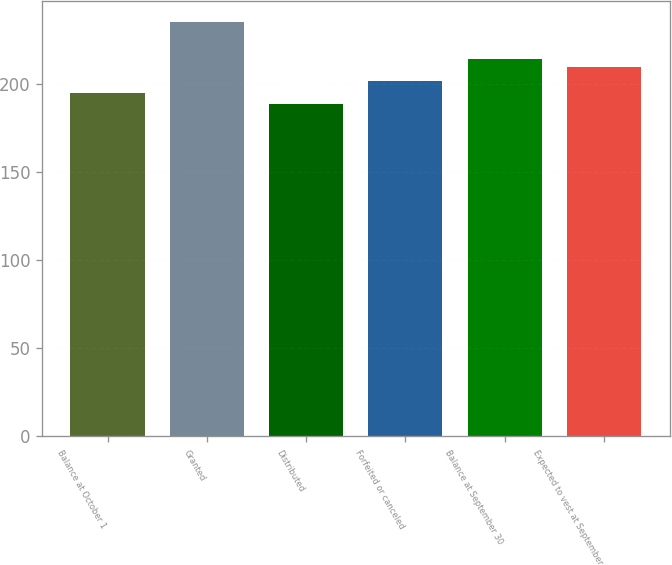Convert chart. <chart><loc_0><loc_0><loc_500><loc_500><bar_chart><fcel>Balance at October 1<fcel>Granted<fcel>Distributed<fcel>Forfeited or canceled<fcel>Balance at September 30<fcel>Expected to vest at September<nl><fcel>194.92<fcel>235.5<fcel>189.06<fcel>201.85<fcel>214.31<fcel>209.67<nl></chart> 